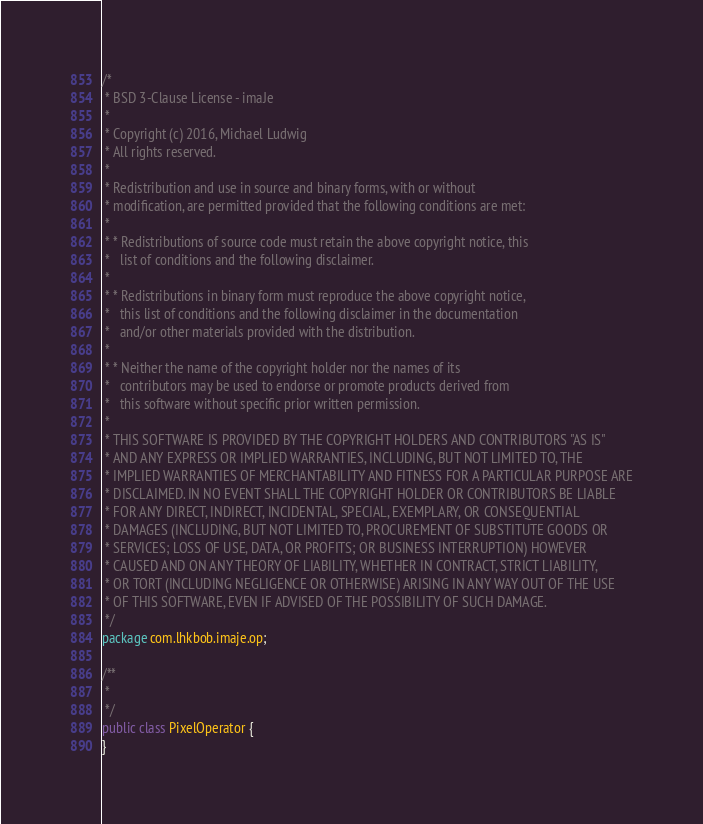<code> <loc_0><loc_0><loc_500><loc_500><_Java_>/*
 * BSD 3-Clause License - imaJe
 *
 * Copyright (c) 2016, Michael Ludwig
 * All rights reserved.
 *
 * Redistribution and use in source and binary forms, with or without
 * modification, are permitted provided that the following conditions are met:
 *
 * * Redistributions of source code must retain the above copyright notice, this
 *   list of conditions and the following disclaimer.
 *
 * * Redistributions in binary form must reproduce the above copyright notice,
 *   this list of conditions and the following disclaimer in the documentation
 *   and/or other materials provided with the distribution.
 *
 * * Neither the name of the copyright holder nor the names of its
 *   contributors may be used to endorse or promote products derived from
 *   this software without specific prior written permission.
 *
 * THIS SOFTWARE IS PROVIDED BY THE COPYRIGHT HOLDERS AND CONTRIBUTORS "AS IS"
 * AND ANY EXPRESS OR IMPLIED WARRANTIES, INCLUDING, BUT NOT LIMITED TO, THE
 * IMPLIED WARRANTIES OF MERCHANTABILITY AND FITNESS FOR A PARTICULAR PURPOSE ARE
 * DISCLAIMED. IN NO EVENT SHALL THE COPYRIGHT HOLDER OR CONTRIBUTORS BE LIABLE
 * FOR ANY DIRECT, INDIRECT, INCIDENTAL, SPECIAL, EXEMPLARY, OR CONSEQUENTIAL
 * DAMAGES (INCLUDING, BUT NOT LIMITED TO, PROCUREMENT OF SUBSTITUTE GOODS OR
 * SERVICES; LOSS OF USE, DATA, OR PROFITS; OR BUSINESS INTERRUPTION) HOWEVER
 * CAUSED AND ON ANY THEORY OF LIABILITY, WHETHER IN CONTRACT, STRICT LIABILITY,
 * OR TORT (INCLUDING NEGLIGENCE OR OTHERWISE) ARISING IN ANY WAY OUT OF THE USE
 * OF THIS SOFTWARE, EVEN IF ADVISED OF THE POSSIBILITY OF SUCH DAMAGE.
 */
package com.lhkbob.imaje.op;

/**
 *
 */
public class PixelOperator {
}
</code> 